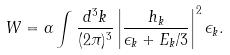<formula> <loc_0><loc_0><loc_500><loc_500>W = \alpha \int \frac { d ^ { 3 } k } { ( 2 \pi ) ^ { 3 } } \left | \frac { h _ { k } } { \epsilon _ { k } + E _ { k } / 3 } \right | ^ { 2 } \epsilon _ { k } .</formula> 